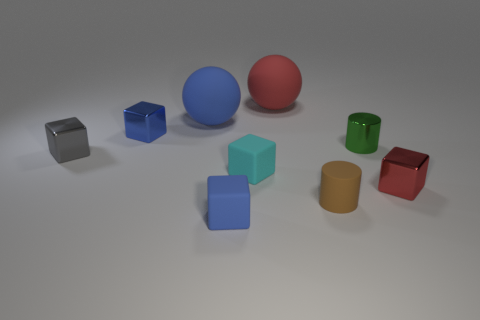Is the color of the tiny metal cylinder the same as the tiny matte cylinder?
Provide a short and direct response. No. How many shiny things are brown objects or tiny purple balls?
Make the answer very short. 0. There is a thing that is left of the tiny blue object that is behind the small green object; is there a tiny cyan rubber block right of it?
Provide a short and direct response. Yes. The cyan block that is the same material as the brown cylinder is what size?
Ensure brevity in your answer.  Small. Are there any large red matte things on the left side of the small cyan rubber block?
Your answer should be very brief. No. There is a metallic cube right of the tiny blue matte object; is there a object that is behind it?
Your answer should be very brief. Yes. There is a shiny block that is on the right side of the green metal cylinder; does it have the same size as the red object behind the small shiny cylinder?
Keep it short and to the point. No. How many small things are brown matte things or blue rubber objects?
Ensure brevity in your answer.  2. What is the material of the red thing in front of the large ball that is on the left side of the red ball?
Offer a terse response. Metal. Are there any tiny gray cubes made of the same material as the small brown cylinder?
Your response must be concise. No. 